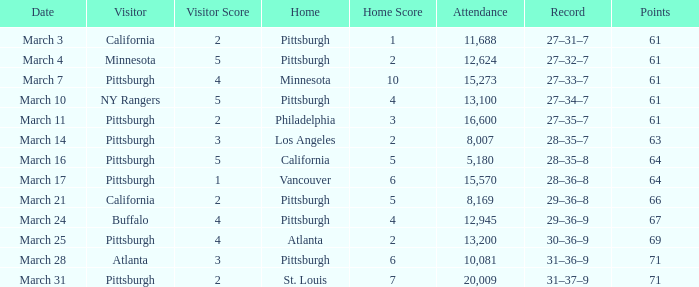What is the Date of the game in Vancouver? March 17. 